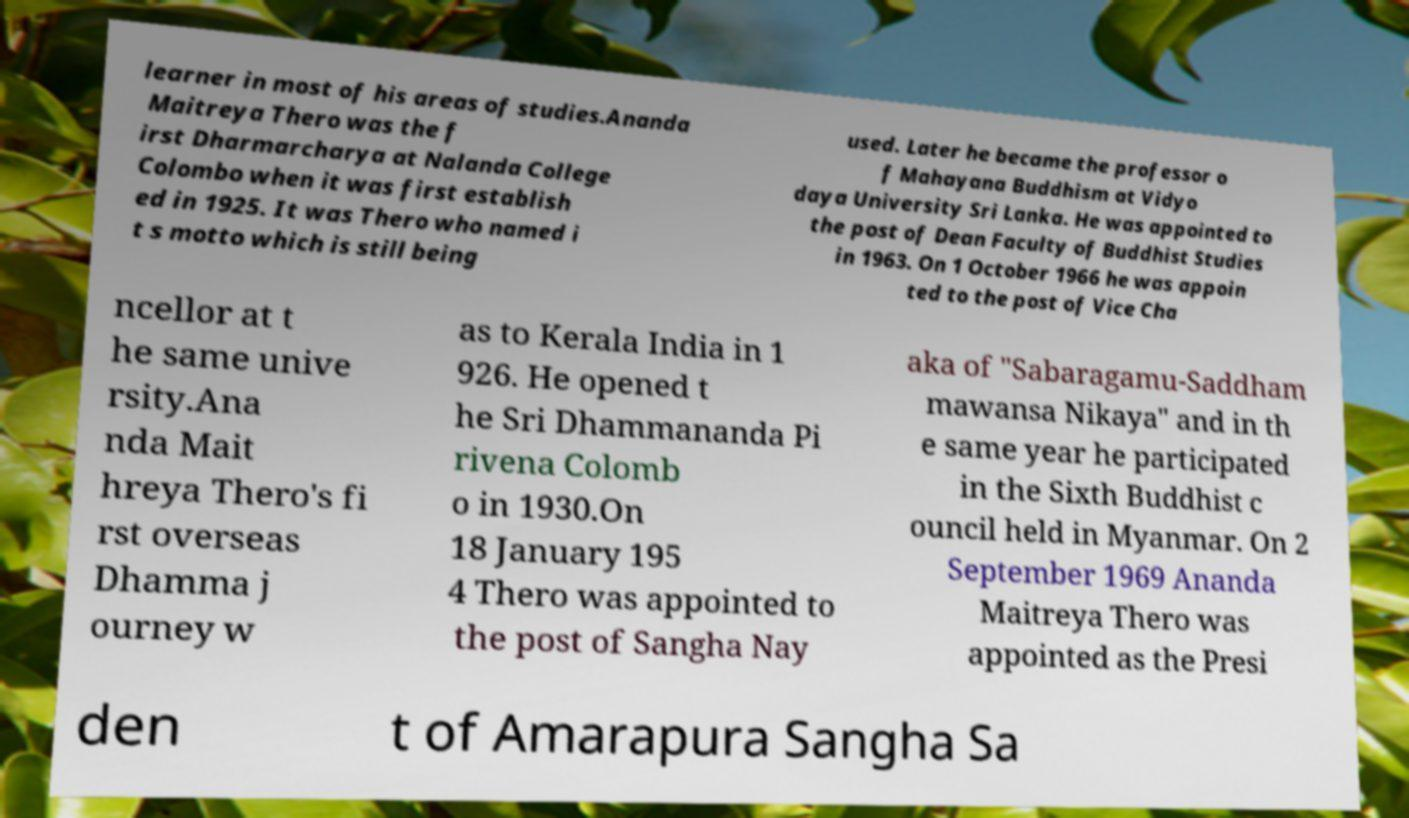Can you accurately transcribe the text from the provided image for me? learner in most of his areas of studies.Ananda Maitreya Thero was the f irst Dharmarcharya at Nalanda College Colombo when it was first establish ed in 1925. It was Thero who named i t s motto which is still being used. Later he became the professor o f Mahayana Buddhism at Vidyo daya University Sri Lanka. He was appointed to the post of Dean Faculty of Buddhist Studies in 1963. On 1 October 1966 he was appoin ted to the post of Vice Cha ncellor at t he same unive rsity.Ana nda Mait hreya Thero's fi rst overseas Dhamma j ourney w as to Kerala India in 1 926. He opened t he Sri Dhammananda Pi rivena Colomb o in 1930.On 18 January 195 4 Thero was appointed to the post of Sangha Nay aka of "Sabaragamu-Saddham mawansa Nikaya" and in th e same year he participated in the Sixth Buddhist c ouncil held in Myanmar. On 2 September 1969 Ananda Maitreya Thero was appointed as the Presi den t of Amarapura Sangha Sa 